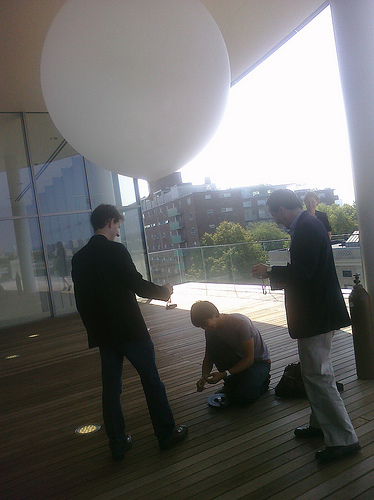<image>
Is there a man above the man? Yes. The man is positioned above the man in the vertical space, higher up in the scene. 